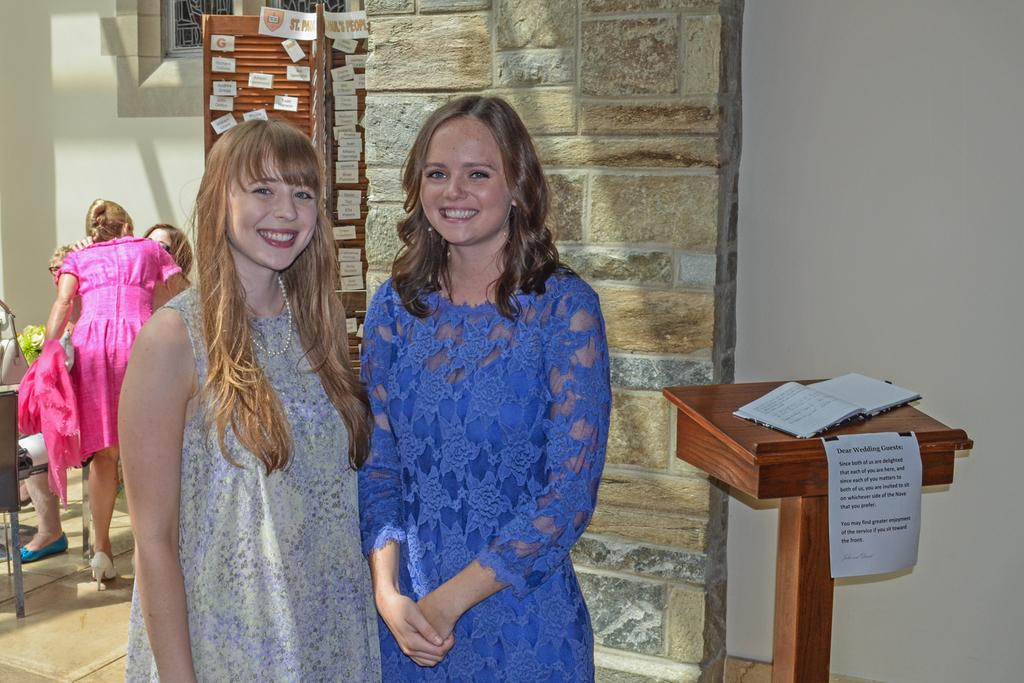How many ladies are in the image? There are two ladies in the image. What colors are the dresses of the ladies? One lady is wearing a blue dress, and the other lady is wearing an ash-colored dress. What type of furniture is in the image? There is a wooden desk in the image. What is on the wooden desk? There are papers on the wooden desk. What type of peace symbol can be seen on the desk in the image? There is no peace symbol present on the desk in the image. 